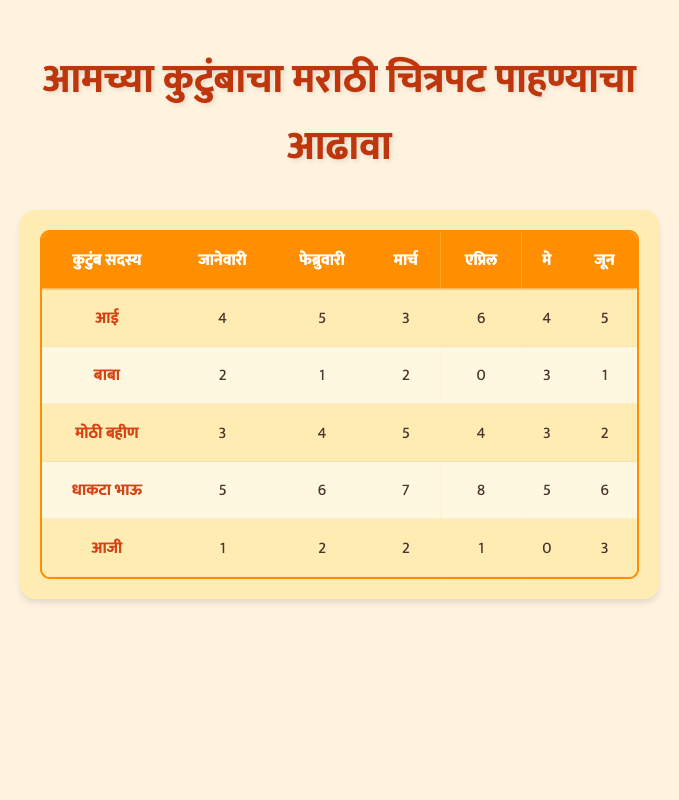What is the total number of Marathi films watched by the Younger Brother in the last six months? To find the total, we sum the values for the Younger Brother from each month: 5 (Jan) + 6 (Feb) + 7 (Mar) + 8 (Apr) + 5 (May) + 6 (Jun) = 37
Answer: 37 Which family member watched the least number of Marathi films in April? In April, we look at the counts of films watched by each family member: Mother (6), Father (0), Elder Sister (4), Younger Brother (8), Grandmother (1); the Father watched the least at 0.
Answer: Father How many films did the Grandmother watch on average over the six months? The Grandmother's monthly totals are: 1 (Jan), 2 (Feb), 2 (Mar), 1 (Apr), 0 (May), 3 (Jun). To find the average, we sum these values (1 + 2 + 2 + 1 + 0 + 3 = 9) and divide by the number of months (6): 9/6 = 1.5.
Answer: 1.5 Did the Mother watch more films than the Elder Sister in February? In February, the Mother watched 5 films and the Elder Sister watched 4 films. Since 5 is greater than 4, the answer is yes.
Answer: Yes What is the difference in the number of films watched by the Father between January and April? The Father watched 2 films in January and 0 in April. The difference is calculated as: 2 (Jan) - 0 (Apr) = 2.
Answer: 2 Who is the most consistent viewer among family members? To determine consistency, we can look at the changes in the number of films watched by each family member over the months. The Mother has varying counts: 4, 5, 3, 6, 4, 5. Analyzing fluctuations, she generally stays within a narrow range compared to others who's numbers fluctuate more widely. Thus, the Mother shows the most consistency.
Answer: Mother How many total films did the Elder Sister watch across all the months? The totals for the Elder Sister are: 3 (Jan) + 4 (Feb) + 5 (Mar) + 4 (Apr) + 3 (May) + 2 (Jun) = 21. Therefore, the total is 21.
Answer: 21 Which month did the Younger Brother watch the most films, and how many did he watch? Observing the monthly totals for the Younger Brother: 5 (Jan), 6 (Feb), 7 (Mar), 8 (Apr), 5 (May), 6 (Jun), the maximum is 8 in April.
Answer: April, 8 Did the Grandmother watch more films in January than in March? The counts for the Grandmother are: 1 (Jan) and 2 (Mar). Comparatively, 1 is less than 2; hence, the answer is no.
Answer: No 